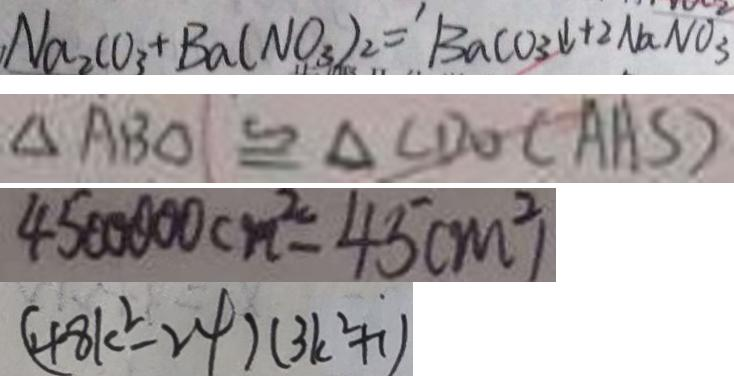Convert formula to latex. <formula><loc_0><loc_0><loc_500><loc_500>N a _ { 2 } C O _ { 3 } + B a ( N O _ { 3 } ) _ { 2 } = B a c o _ { 3 } \downarrow + 2 N a N O _ { 3 } 
 \Delta A B O \cong \Delta C D O ( A A S ) 
 4 5 0 0 0 0 0 c m ^ { 2 } = 4 5 ( m ^ { 2 } ) 
 ( 4 8 k ^ { 2 } - 2 4 ) ( 3 k ^ { 2 } + 1 )</formula> 